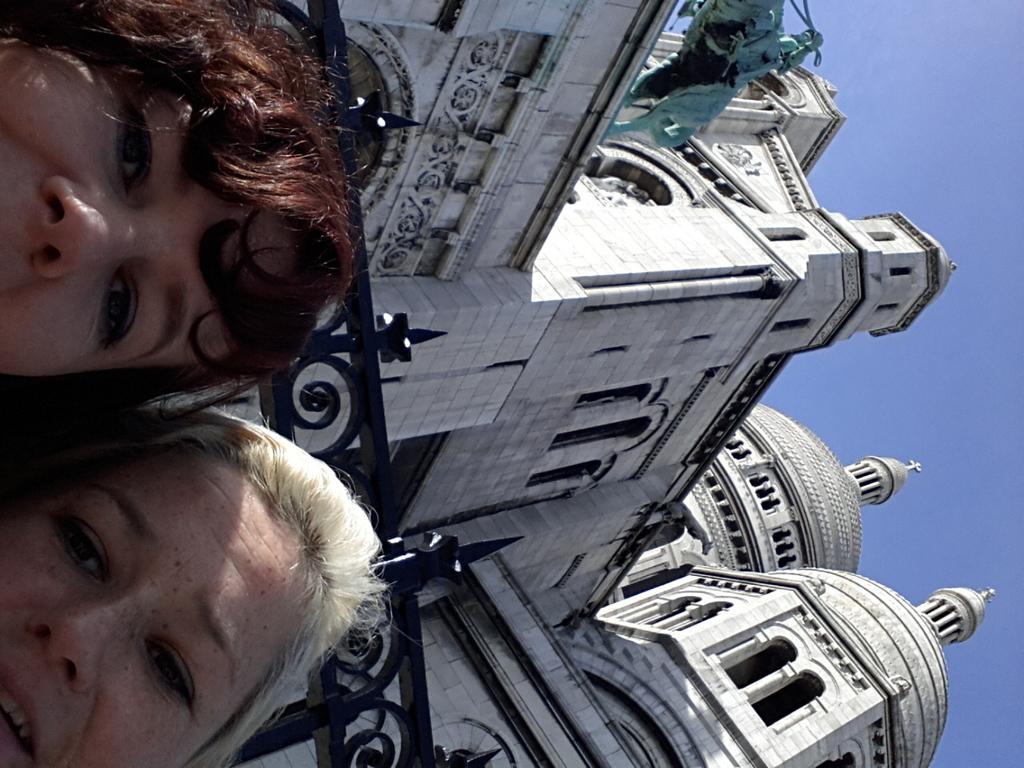In one or two sentences, can you explain what this image depicts? It is a tilted image there are two people in the front and behind them there is a huge architecture, on the left side there is a sculpture. 